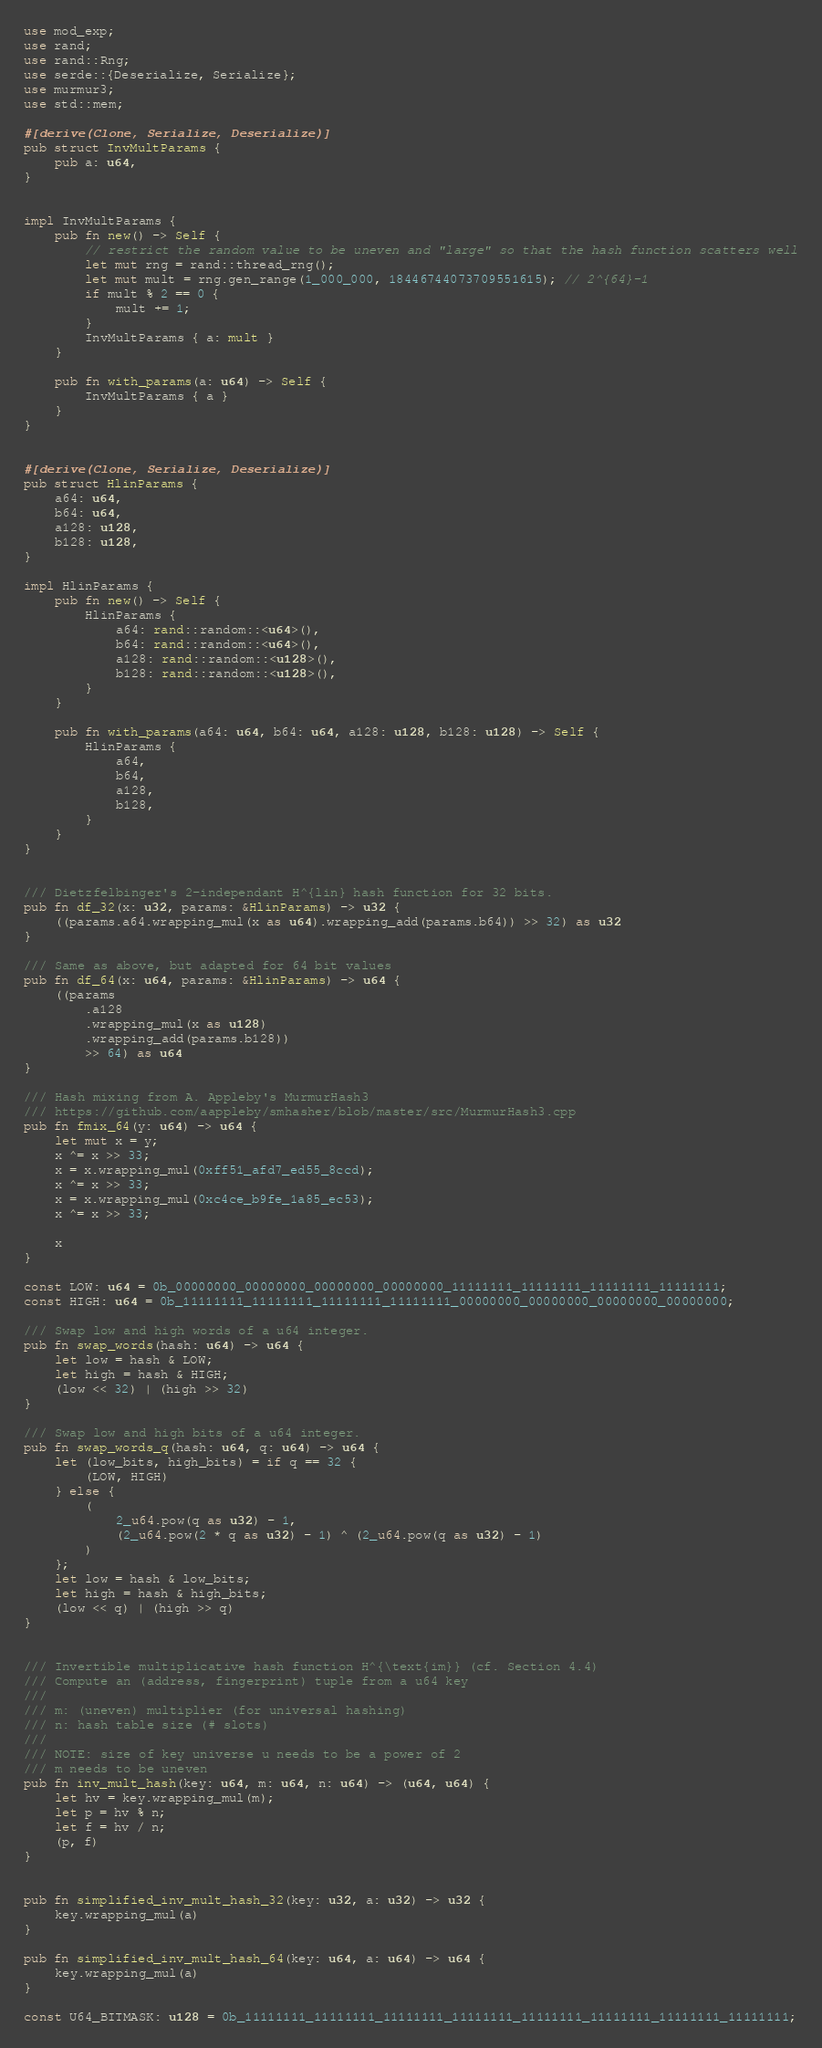Convert code to text. <code><loc_0><loc_0><loc_500><loc_500><_Rust_>use mod_exp;
use rand;
use rand::Rng;
use serde::{Deserialize, Serialize};
use murmur3;
use std::mem;

#[derive(Clone, Serialize, Deserialize)]
pub struct InvMultParams {
    pub a: u64,
}


impl InvMultParams {
    pub fn new() -> Self {
        // restrict the random value to be uneven and "large" so that the hash function scatters well
        let mut rng = rand::thread_rng();
        let mut mult = rng.gen_range(1_000_000, 18446744073709551615); // 2^{64}-1
        if mult % 2 == 0 {
            mult += 1;
        }
        InvMultParams { a: mult }
    }

    pub fn with_params(a: u64) -> Self {
        InvMultParams { a }
    }
}


#[derive(Clone, Serialize, Deserialize)]
pub struct HlinParams {
    a64: u64,
    b64: u64,
    a128: u128,
    b128: u128,
}

impl HlinParams {
    pub fn new() -> Self {
        HlinParams {
            a64: rand::random::<u64>(),
            b64: rand::random::<u64>(),
            a128: rand::random::<u128>(),
            b128: rand::random::<u128>(),
        }
    }

    pub fn with_params(a64: u64, b64: u64, a128: u128, b128: u128) -> Self {
        HlinParams {
            a64,
            b64,
            a128,
            b128,
        }
    }
}


/// Dietzfelbinger's 2-independant H^{lin} hash function for 32 bits.
pub fn df_32(x: u32, params: &HlinParams) -> u32 {
    ((params.a64.wrapping_mul(x as u64).wrapping_add(params.b64)) >> 32) as u32
}

/// Same as above, but adapted for 64 bit values
pub fn df_64(x: u64, params: &HlinParams) -> u64 {
    ((params
        .a128
        .wrapping_mul(x as u128)
        .wrapping_add(params.b128))
        >> 64) as u64
}

/// Hash mixing from A. Appleby's MurmurHash3
/// https://github.com/aappleby/smhasher/blob/master/src/MurmurHash3.cpp
pub fn fmix_64(y: u64) -> u64 {
    let mut x = y;
    x ^= x >> 33;
    x = x.wrapping_mul(0xff51_afd7_ed55_8ccd);
    x ^= x >> 33;
    x = x.wrapping_mul(0xc4ce_b9fe_1a85_ec53);
    x ^= x >> 33;

    x
}

const LOW: u64 = 0b_00000000_00000000_00000000_00000000_11111111_11111111_11111111_11111111;
const HIGH: u64 = 0b_11111111_11111111_11111111_11111111_00000000_00000000_00000000_00000000;

/// Swap low and high words of a u64 integer.
pub fn swap_words(hash: u64) -> u64 {
    let low = hash & LOW;
    let high = hash & HIGH;
    (low << 32) | (high >> 32)
}

/// Swap low and high bits of a u64 integer.
pub fn swap_words_q(hash: u64, q: u64) -> u64 {
    let (low_bits, high_bits) = if q == 32 {
        (LOW, HIGH)
    } else {
        (
            2_u64.pow(q as u32) - 1,
            (2_u64.pow(2 * q as u32) - 1) ^ (2_u64.pow(q as u32) - 1)
        )
    };
    let low = hash & low_bits;
    let high = hash & high_bits;
    (low << q) | (high >> q)
}


/// Invertible multiplicative hash function H^{\text{im}} (cf. Section 4.4)
/// Compute an (address, fingerprint) tuple from a u64 key
///
/// m: (uneven) multiplier (for universal hashing)
/// n: hash table size (# slots)
/// 
/// NOTE: size of key universe u needs to be a power of 2
/// m needs to be uneven
pub fn inv_mult_hash(key: u64, m: u64, n: u64) -> (u64, u64) {
    let hv = key.wrapping_mul(m);
    let p = hv % n;
    let f = hv / n;
    (p, f)
}


pub fn simplified_inv_mult_hash_32(key: u32, a: u32) -> u32 {
    key.wrapping_mul(a)
}

pub fn simplified_inv_mult_hash_64(key: u64, a: u64) -> u64 {
    key.wrapping_mul(a)
}

const U64_BITMASK: u128 = 0b_11111111_11111111_11111111_11111111_11111111_11111111_11111111_11111111;
</code> 